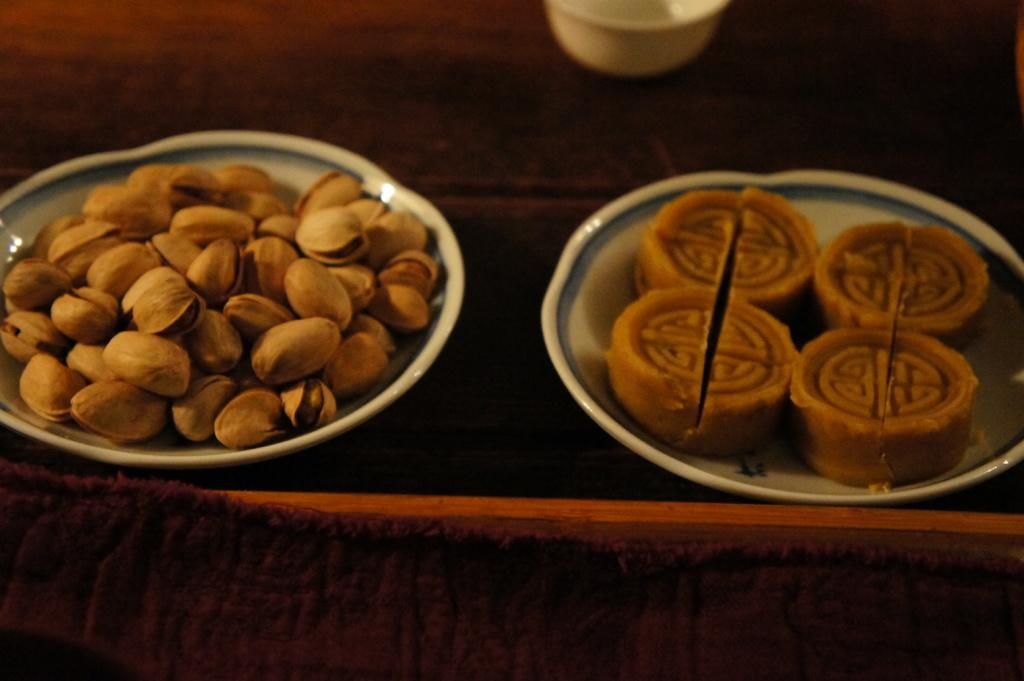What type of furniture is present in the image? There is a table in the image. What celestial bodies are depicted in the image? There are planets depicted in the image. What type of food items can be seen in the image? There are sweets and nuts in the image. What is used to hold the food items in the image? There is a bowl in the image. What type of material is present in the image? There is a cloth in the image. Can you tell me how many fish are swimming in the bowl in the image? There are no fish present in the image; the bowl contains sweets and nuts. What type of musical instrument is being played in the image? There is no musical instrument present in the image. 